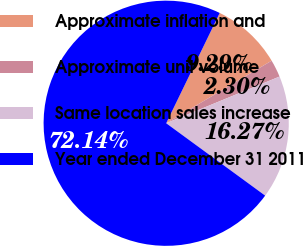<chart> <loc_0><loc_0><loc_500><loc_500><pie_chart><fcel>Approximate inflation and<fcel>Approximate unit volume<fcel>Same location sales increase<fcel>Year ended December 31 2011<nl><fcel>9.29%<fcel>2.3%<fcel>16.27%<fcel>72.14%<nl></chart> 